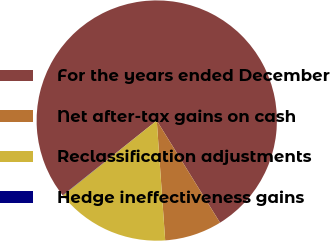Convert chart. <chart><loc_0><loc_0><loc_500><loc_500><pie_chart><fcel>For the years ended December<fcel>Net after-tax gains on cash<fcel>Reclassification adjustments<fcel>Hedge ineffectiveness gains<nl><fcel>76.86%<fcel>7.71%<fcel>15.4%<fcel>0.03%<nl></chart> 